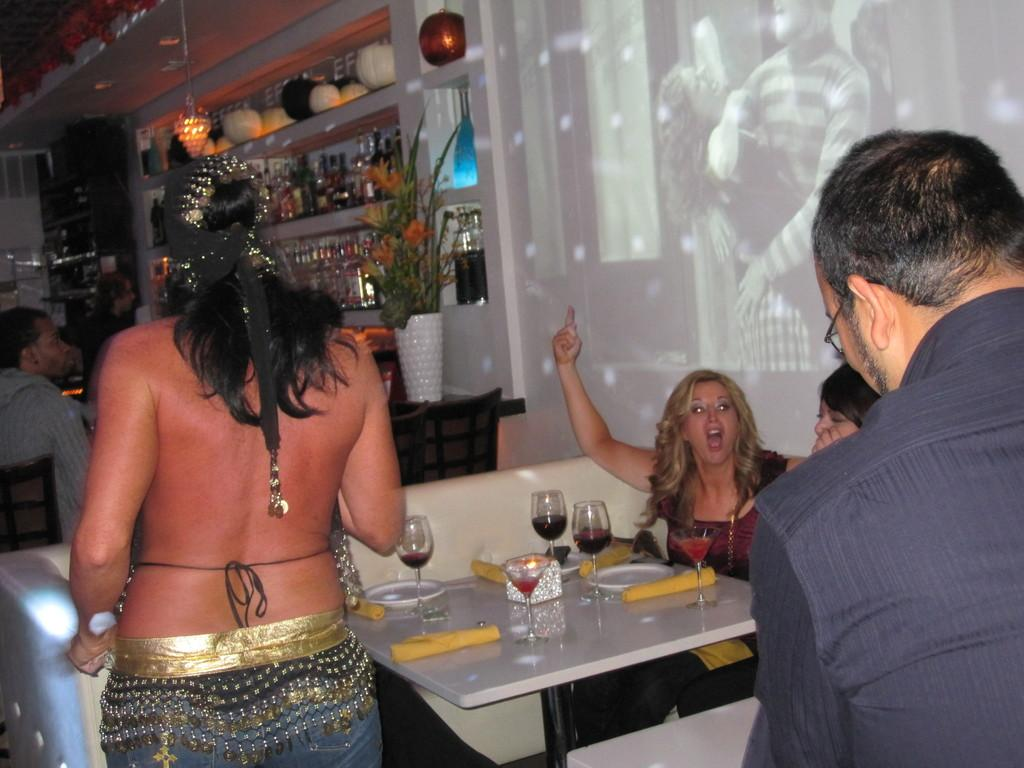What is the primary action of the person in the image? There is a person standing in the image. What are the other people in the image doing? There are people sitting in the image. What is present on which the people are sitting or standing? There is a table in the image. What can be seen on the table? There are wine glasses on the table. What type of wound can be seen on the person sitting in the image? There is no wound visible on any person in the image. How many people are laughing in the image? There is no indication of anyone laughing in the image. 